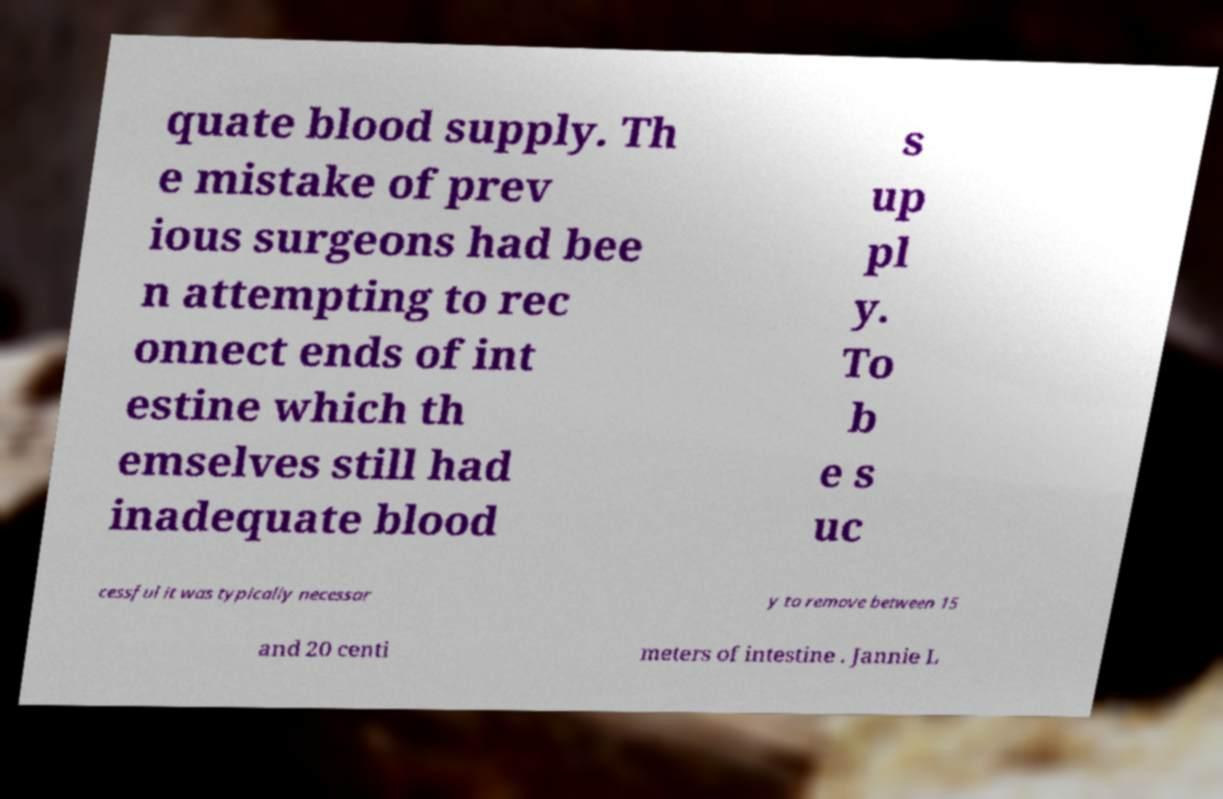Can you accurately transcribe the text from the provided image for me? quate blood supply. Th e mistake of prev ious surgeons had bee n attempting to rec onnect ends of int estine which th emselves still had inadequate blood s up pl y. To b e s uc cessful it was typically necessar y to remove between 15 and 20 centi meters of intestine . Jannie L 